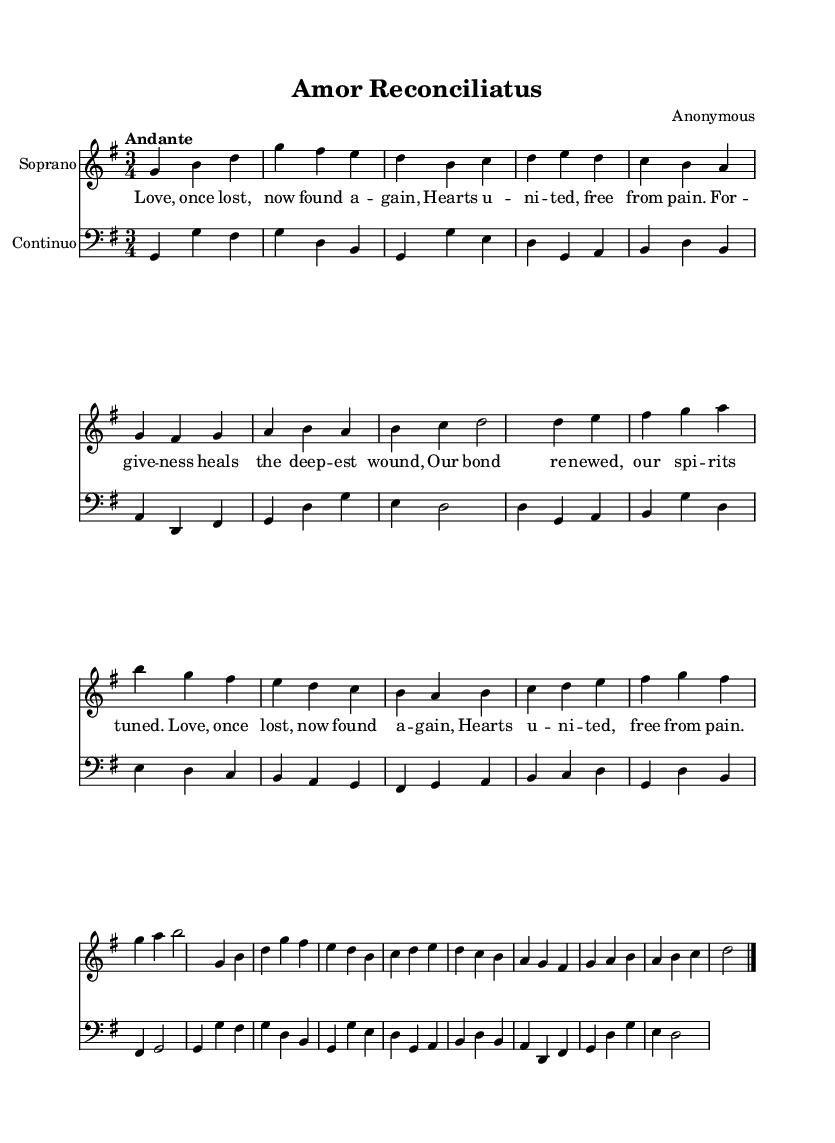What is the key signature of this music? The key signature is determined by analyzing the following notes in the music. It has one sharp, which indicates that it is in G major.
Answer: G major What is the time signature of this piece? The time signature can be found at the beginning of the score, which shows the music is written in 3 beats per measure.
Answer: 3/4 What is the tempo marking indicated in the score? The tempo marking is noted at the beginning of the sheet music. In this case, it is marked as "Andante," which indicates a moderately slow tempo.
Answer: Andante How many sections are included in the melodic structure? By closely examining the layout, the music comprises two distinct sections (A and B), with a return to the A section at the end.
Answer: 3 Which instrument is indicated for the bass line? The bass line is indicated with the clef marking at the beginning of the continuo staff, showing that it is set for the bass clef.
Answer: Harpsichord What thematic element does the lyrics convey? The lyrics express themes of reconciliation and healing in relationships, as it mentions forgiveness and unity following a period of loss.
Answer: Reconciliation What is the formal structure of the aria? By analyzing the arrangement and return of musical themes, the structure follows the form of A-B-A, which is typical in Baroque arias.
Answer: A-B-A 